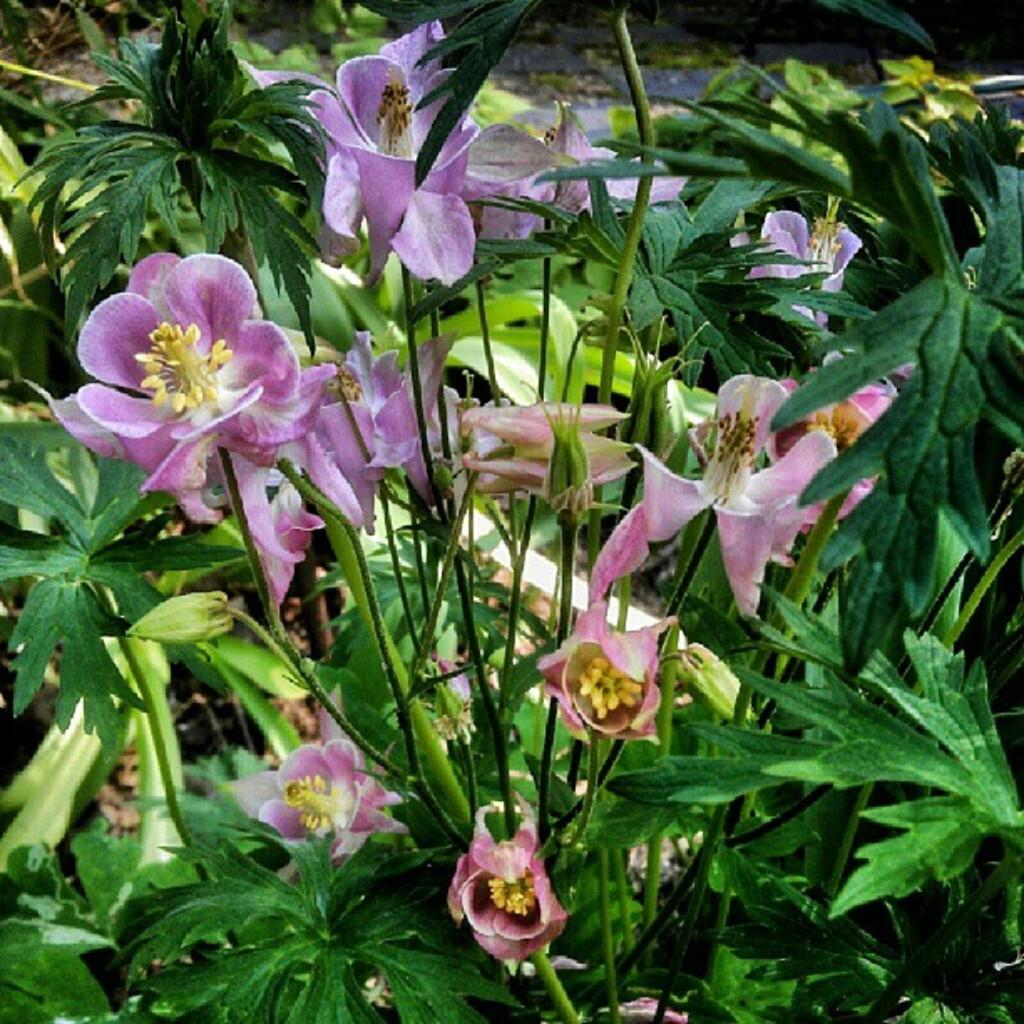Where was the image taken? The image was taken outdoors. What type of vegetation can be seen in the image? There are plants with green leaves in the image. What additional features can be observed in the plants? There are beautiful flowers in the image. What is the color of the flowers? The flowers are purple in color. How does the soap help the flowers in the image? There is no soap present in the image, and therefore it cannot help the flowers. 